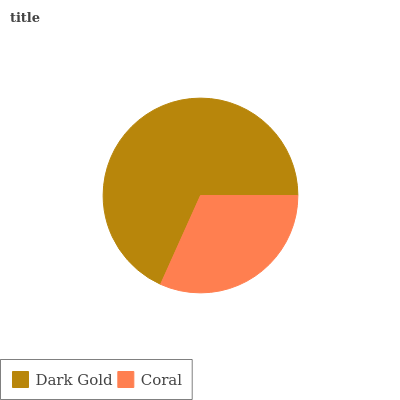Is Coral the minimum?
Answer yes or no. Yes. Is Dark Gold the maximum?
Answer yes or no. Yes. Is Coral the maximum?
Answer yes or no. No. Is Dark Gold greater than Coral?
Answer yes or no. Yes. Is Coral less than Dark Gold?
Answer yes or no. Yes. Is Coral greater than Dark Gold?
Answer yes or no. No. Is Dark Gold less than Coral?
Answer yes or no. No. Is Dark Gold the high median?
Answer yes or no. Yes. Is Coral the low median?
Answer yes or no. Yes. Is Coral the high median?
Answer yes or no. No. Is Dark Gold the low median?
Answer yes or no. No. 